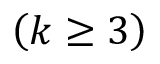Convert formula to latex. <formula><loc_0><loc_0><loc_500><loc_500>\left ( k \geq 3 \right )</formula> 